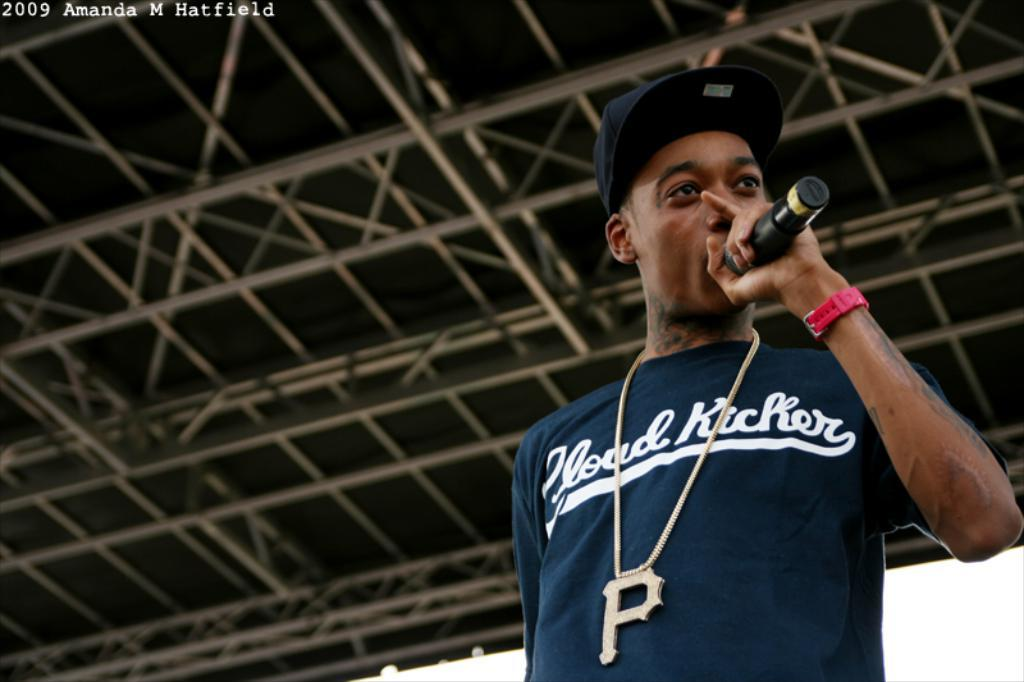What is the person in the image doing? The person is holding a Mic in the image. Where is the person located in the image? The person is on the right side of the image. What can be seen in the background of the image? There is a roof in the background of the image. What is the amusement rate of the person in the image? There is no information about an amusement rate in the image, as it focuses on the person holding a Mic. 